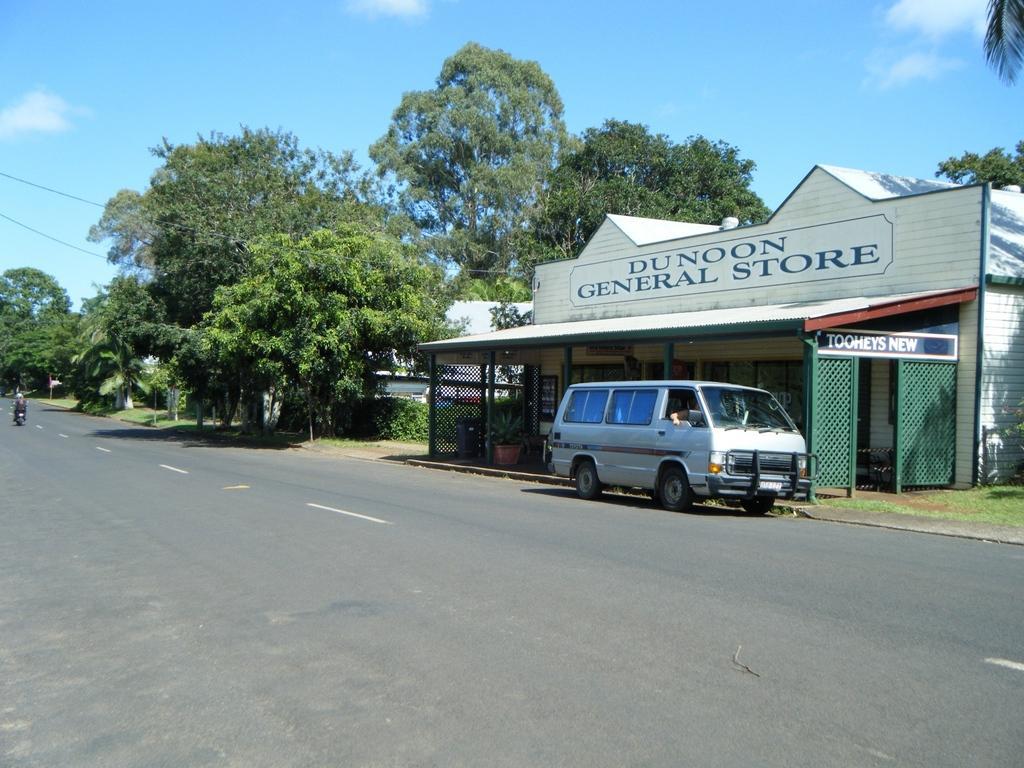Could you give a brief overview of what you see in this image? The picture is taken outside a city. In the foreground of the picture it is road. In the center of the picture there are trees, cables, buildings, plants, grass and a van. Sky is clear and it is sunny. 